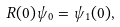<formula> <loc_0><loc_0><loc_500><loc_500>R ( 0 ) \psi _ { 0 } = \psi _ { 1 } ( 0 ) ,</formula> 